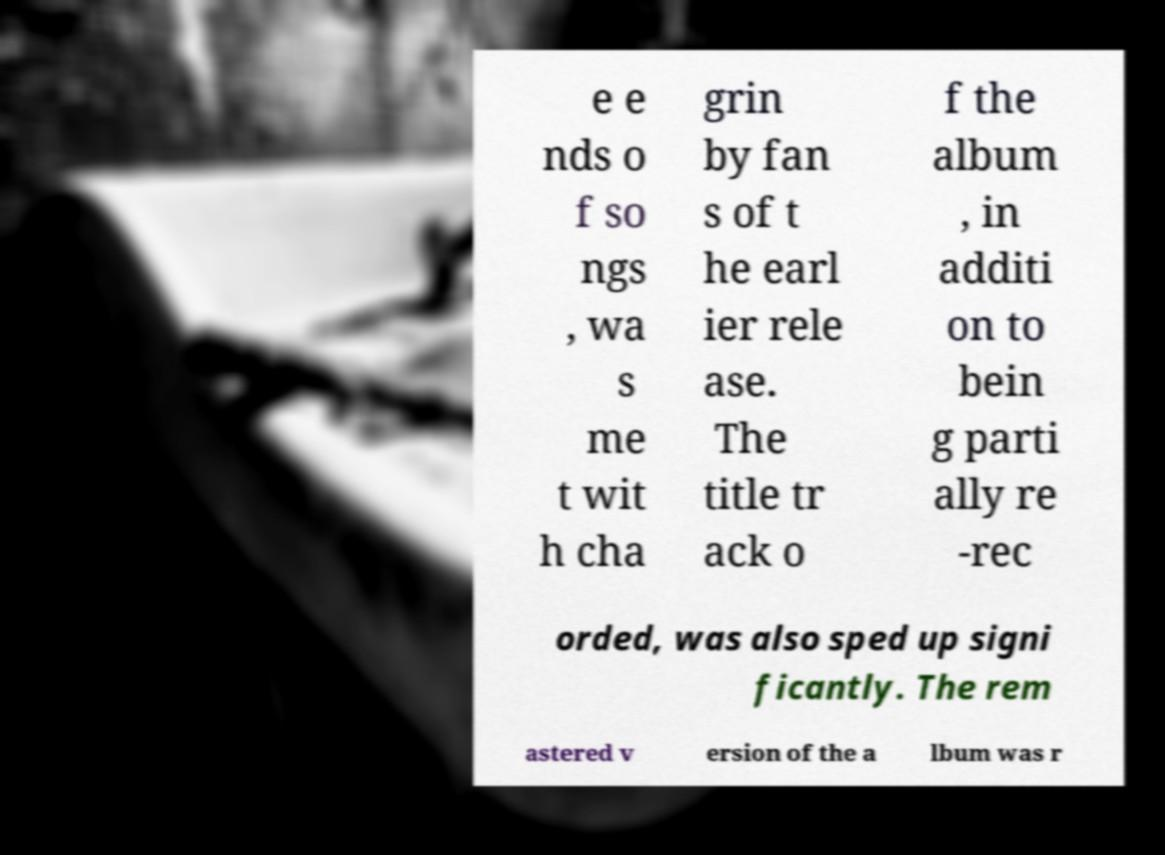What messages or text are displayed in this image? I need them in a readable, typed format. e e nds o f so ngs , wa s me t wit h cha grin by fan s of t he earl ier rele ase. The title tr ack o f the album , in additi on to bein g parti ally re -rec orded, was also sped up signi ficantly. The rem astered v ersion of the a lbum was r 